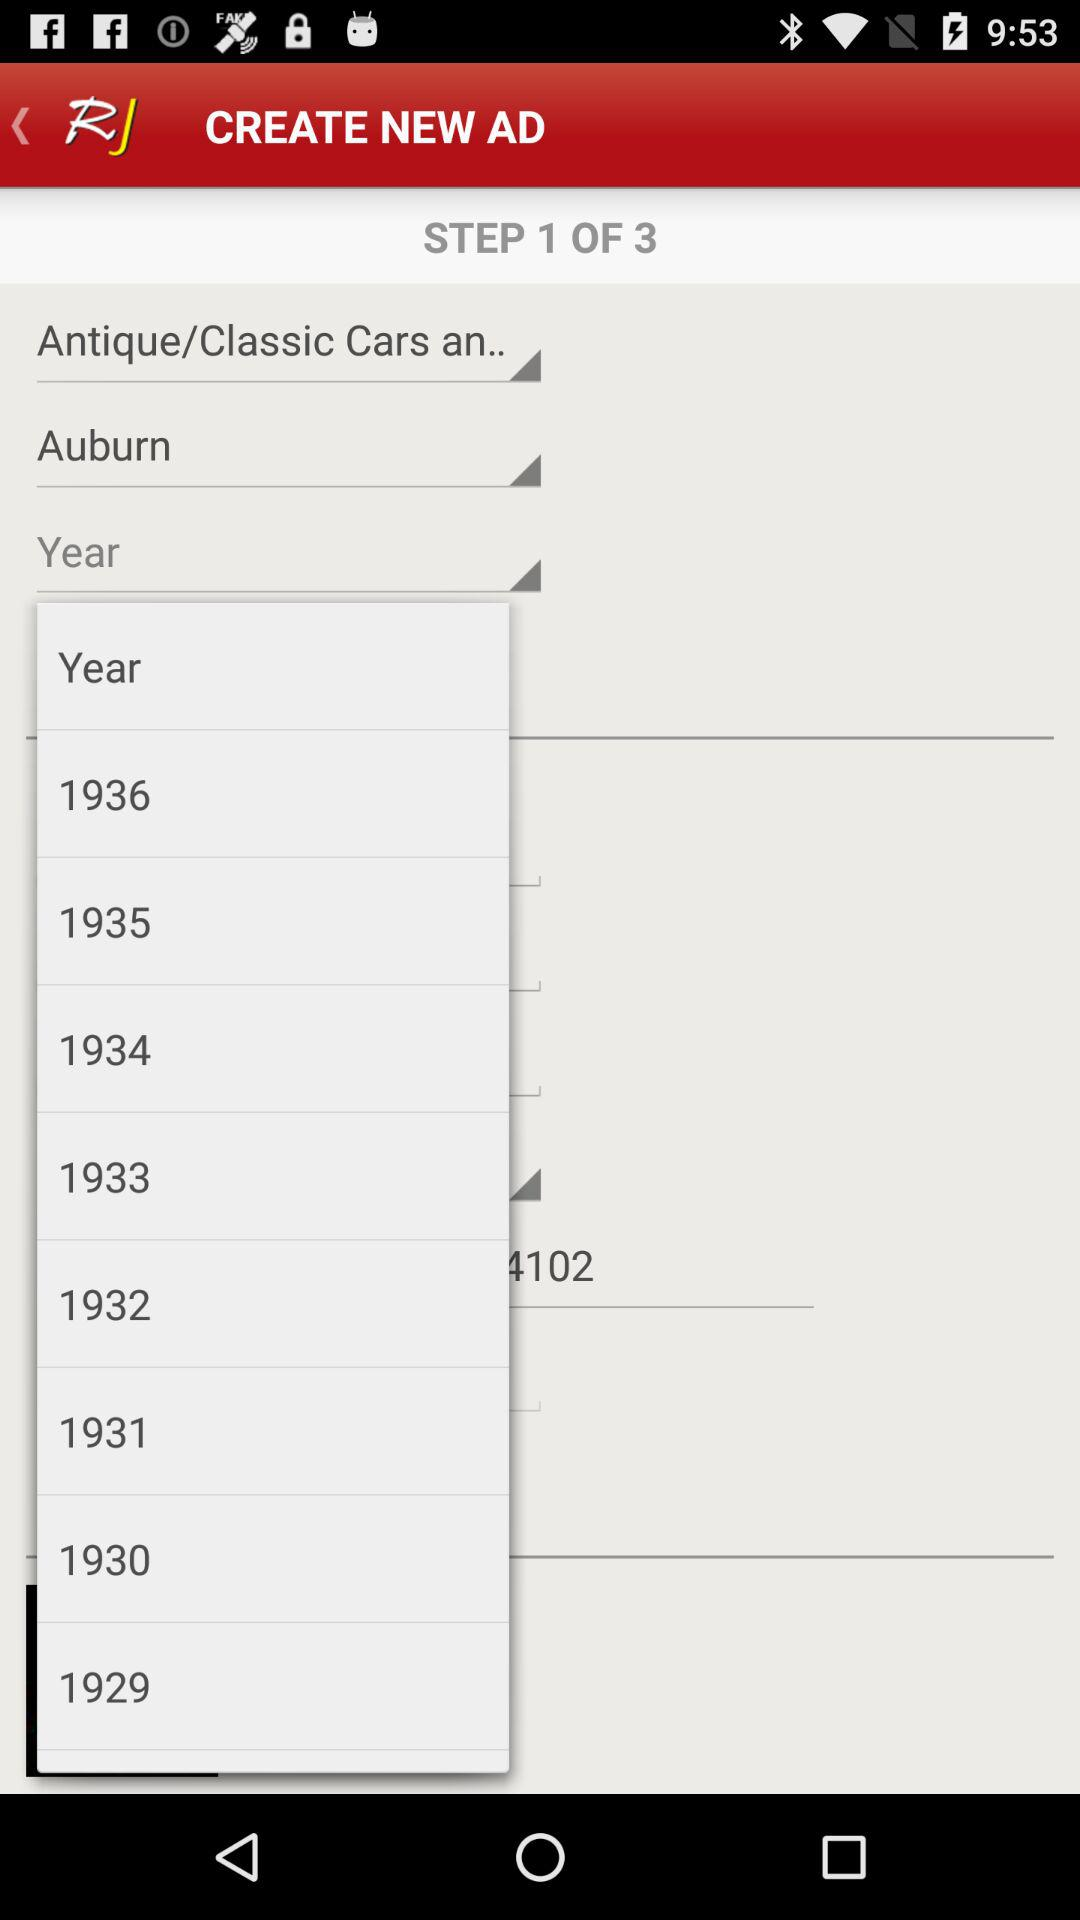What is the current step? The current step is 1. 